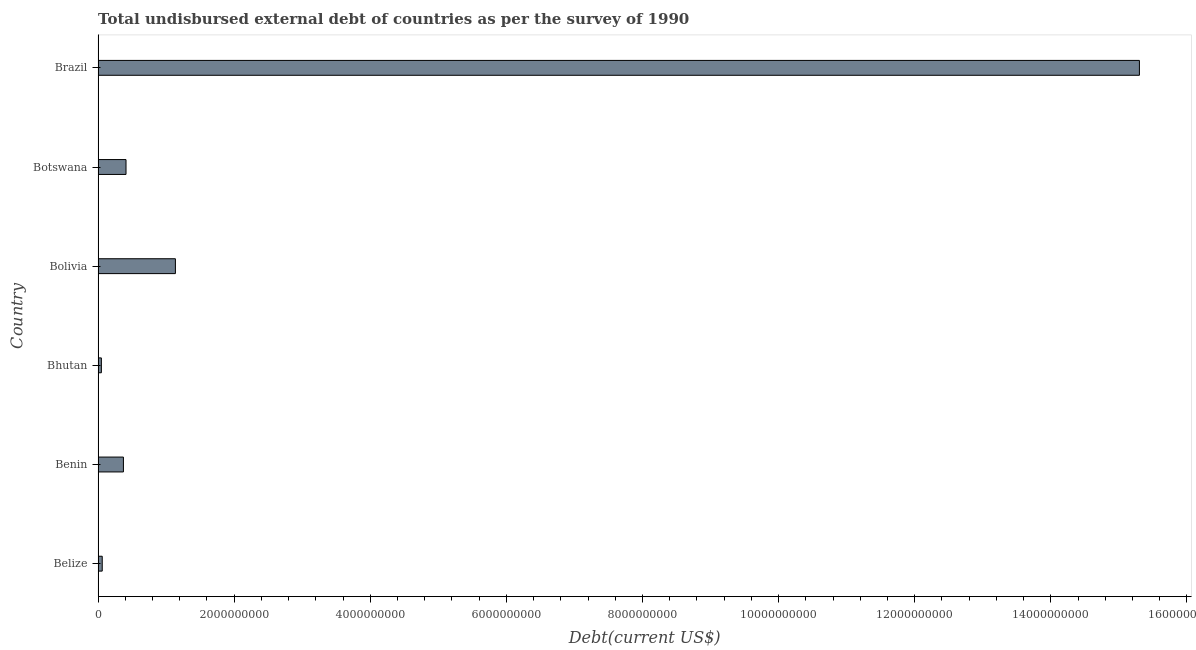Does the graph contain any zero values?
Your response must be concise. No. What is the title of the graph?
Make the answer very short. Total undisbursed external debt of countries as per the survey of 1990. What is the label or title of the X-axis?
Your answer should be compact. Debt(current US$). What is the total debt in Bhutan?
Ensure brevity in your answer.  4.84e+07. Across all countries, what is the maximum total debt?
Provide a succinct answer. 1.53e+1. Across all countries, what is the minimum total debt?
Your response must be concise. 4.84e+07. In which country was the total debt maximum?
Offer a very short reply. Brazil. In which country was the total debt minimum?
Offer a very short reply. Bhutan. What is the sum of the total debt?
Provide a succinct answer. 1.73e+1. What is the difference between the total debt in Bhutan and Bolivia?
Keep it short and to the point. -1.09e+09. What is the average total debt per country?
Provide a succinct answer. 2.89e+09. What is the median total debt?
Your answer should be compact. 3.91e+08. What is the ratio of the total debt in Benin to that in Bhutan?
Your response must be concise. 7.69. Is the difference between the total debt in Belize and Botswana greater than the difference between any two countries?
Your answer should be compact. No. What is the difference between the highest and the second highest total debt?
Give a very brief answer. 1.42e+1. Is the sum of the total debt in Benin and Bhutan greater than the maximum total debt across all countries?
Ensure brevity in your answer.  No. What is the difference between the highest and the lowest total debt?
Offer a very short reply. 1.53e+1. Are all the bars in the graph horizontal?
Keep it short and to the point. Yes. How many countries are there in the graph?
Your answer should be compact. 6. What is the difference between two consecutive major ticks on the X-axis?
Offer a very short reply. 2.00e+09. Are the values on the major ticks of X-axis written in scientific E-notation?
Keep it short and to the point. No. What is the Debt(current US$) of Belize?
Provide a short and direct response. 6.09e+07. What is the Debt(current US$) in Benin?
Provide a succinct answer. 3.72e+08. What is the Debt(current US$) of Bhutan?
Give a very brief answer. 4.84e+07. What is the Debt(current US$) of Bolivia?
Keep it short and to the point. 1.14e+09. What is the Debt(current US$) of Botswana?
Offer a very short reply. 4.10e+08. What is the Debt(current US$) in Brazil?
Your response must be concise. 1.53e+1. What is the difference between the Debt(current US$) in Belize and Benin?
Provide a short and direct response. -3.11e+08. What is the difference between the Debt(current US$) in Belize and Bhutan?
Provide a short and direct response. 1.25e+07. What is the difference between the Debt(current US$) in Belize and Bolivia?
Provide a succinct answer. -1.08e+09. What is the difference between the Debt(current US$) in Belize and Botswana?
Offer a terse response. -3.49e+08. What is the difference between the Debt(current US$) in Belize and Brazil?
Keep it short and to the point. -1.52e+1. What is the difference between the Debt(current US$) in Benin and Bhutan?
Offer a very short reply. 3.24e+08. What is the difference between the Debt(current US$) in Benin and Bolivia?
Provide a short and direct response. -7.64e+08. What is the difference between the Debt(current US$) in Benin and Botswana?
Provide a short and direct response. -3.80e+07. What is the difference between the Debt(current US$) in Benin and Brazil?
Offer a terse response. -1.49e+1. What is the difference between the Debt(current US$) in Bhutan and Bolivia?
Your answer should be compact. -1.09e+09. What is the difference between the Debt(current US$) in Bhutan and Botswana?
Offer a very short reply. -3.62e+08. What is the difference between the Debt(current US$) in Bhutan and Brazil?
Your answer should be very brief. -1.53e+1. What is the difference between the Debt(current US$) in Bolivia and Botswana?
Your response must be concise. 7.26e+08. What is the difference between the Debt(current US$) in Bolivia and Brazil?
Provide a succinct answer. -1.42e+1. What is the difference between the Debt(current US$) in Botswana and Brazil?
Ensure brevity in your answer.  -1.49e+1. What is the ratio of the Debt(current US$) in Belize to that in Benin?
Your answer should be very brief. 0.16. What is the ratio of the Debt(current US$) in Belize to that in Bhutan?
Offer a very short reply. 1.26. What is the ratio of the Debt(current US$) in Belize to that in Bolivia?
Your answer should be very brief. 0.05. What is the ratio of the Debt(current US$) in Belize to that in Botswana?
Your answer should be very brief. 0.15. What is the ratio of the Debt(current US$) in Belize to that in Brazil?
Offer a terse response. 0. What is the ratio of the Debt(current US$) in Benin to that in Bhutan?
Ensure brevity in your answer.  7.69. What is the ratio of the Debt(current US$) in Benin to that in Bolivia?
Give a very brief answer. 0.33. What is the ratio of the Debt(current US$) in Benin to that in Botswana?
Provide a succinct answer. 0.91. What is the ratio of the Debt(current US$) in Benin to that in Brazil?
Your answer should be very brief. 0.02. What is the ratio of the Debt(current US$) in Bhutan to that in Bolivia?
Offer a very short reply. 0.04. What is the ratio of the Debt(current US$) in Bhutan to that in Botswana?
Your answer should be very brief. 0.12. What is the ratio of the Debt(current US$) in Bhutan to that in Brazil?
Your answer should be very brief. 0. What is the ratio of the Debt(current US$) in Bolivia to that in Botswana?
Provide a short and direct response. 2.77. What is the ratio of the Debt(current US$) in Bolivia to that in Brazil?
Offer a very short reply. 0.07. What is the ratio of the Debt(current US$) in Botswana to that in Brazil?
Keep it short and to the point. 0.03. 